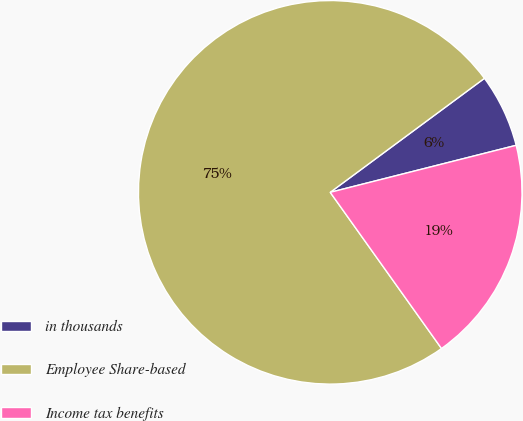<chart> <loc_0><loc_0><loc_500><loc_500><pie_chart><fcel>in thousands<fcel>Employee Share-based<fcel>Income tax benefits<nl><fcel>6.19%<fcel>74.72%<fcel>19.09%<nl></chart> 